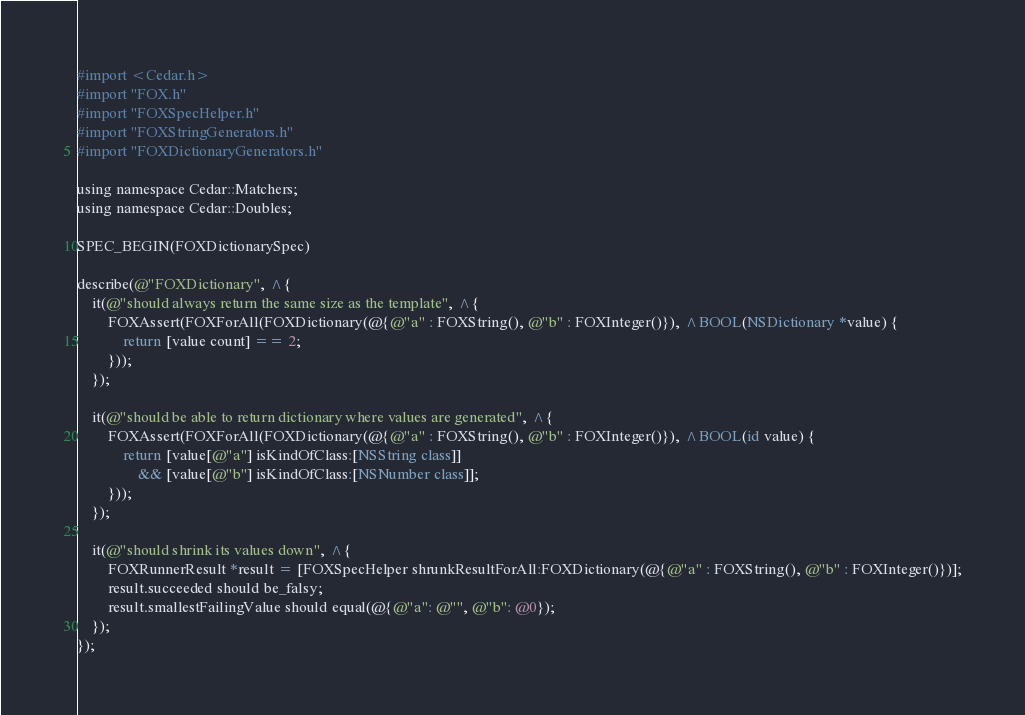Convert code to text. <code><loc_0><loc_0><loc_500><loc_500><_ObjectiveC_>#import <Cedar.h>
#import "FOX.h"
#import "FOXSpecHelper.h"
#import "FOXStringGenerators.h"
#import "FOXDictionaryGenerators.h"

using namespace Cedar::Matchers;
using namespace Cedar::Doubles;

SPEC_BEGIN(FOXDictionarySpec)

describe(@"FOXDictionary", ^{
    it(@"should always return the same size as the template", ^{
        FOXAssert(FOXForAll(FOXDictionary(@{@"a" : FOXString(), @"b" : FOXInteger()}), ^BOOL(NSDictionary *value) {
            return [value count] == 2;
        }));
    });

    it(@"should be able to return dictionary where values are generated", ^{
        FOXAssert(FOXForAll(FOXDictionary(@{@"a" : FOXString(), @"b" : FOXInteger()}), ^BOOL(id value) {
            return [value[@"a"] isKindOfClass:[NSString class]]
                && [value[@"b"] isKindOfClass:[NSNumber class]];
        }));
    });

    it(@"should shrink its values down", ^{
        FOXRunnerResult *result = [FOXSpecHelper shrunkResultForAll:FOXDictionary(@{@"a" : FOXString(), @"b" : FOXInteger()})];
        result.succeeded should be_falsy;
        result.smallestFailingValue should equal(@{@"a": @"", @"b": @0});
    });
});
</code> 